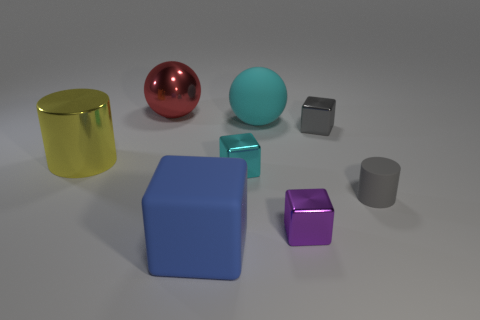There is a small cube that is the same color as the tiny rubber object; what is it made of?
Ensure brevity in your answer.  Metal. Are there more small blue cubes than tiny metal blocks?
Your answer should be very brief. No. Are any large gray spheres visible?
Keep it short and to the point. No. How many things are big shiny things behind the yellow cylinder or metal cubes that are left of the tiny gray block?
Give a very brief answer. 3. Is the number of shiny blocks less than the number of green matte things?
Make the answer very short. No. There is a yellow metal cylinder; are there any large rubber things in front of it?
Offer a terse response. Yes. Is the material of the tiny purple thing the same as the small gray cylinder?
Offer a terse response. No. The small thing that is the same shape as the large yellow metal thing is what color?
Ensure brevity in your answer.  Gray. There is a matte thing that is on the right side of the purple shiny thing; does it have the same color as the metallic ball?
Ensure brevity in your answer.  No. How many big blue cubes have the same material as the tiny cyan block?
Provide a succinct answer. 0. 